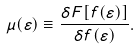Convert formula to latex. <formula><loc_0><loc_0><loc_500><loc_500>\mu ( \varepsilon ) \equiv \frac { \delta F [ f ( \varepsilon ) ] } { \delta f ( \varepsilon ) } .</formula> 